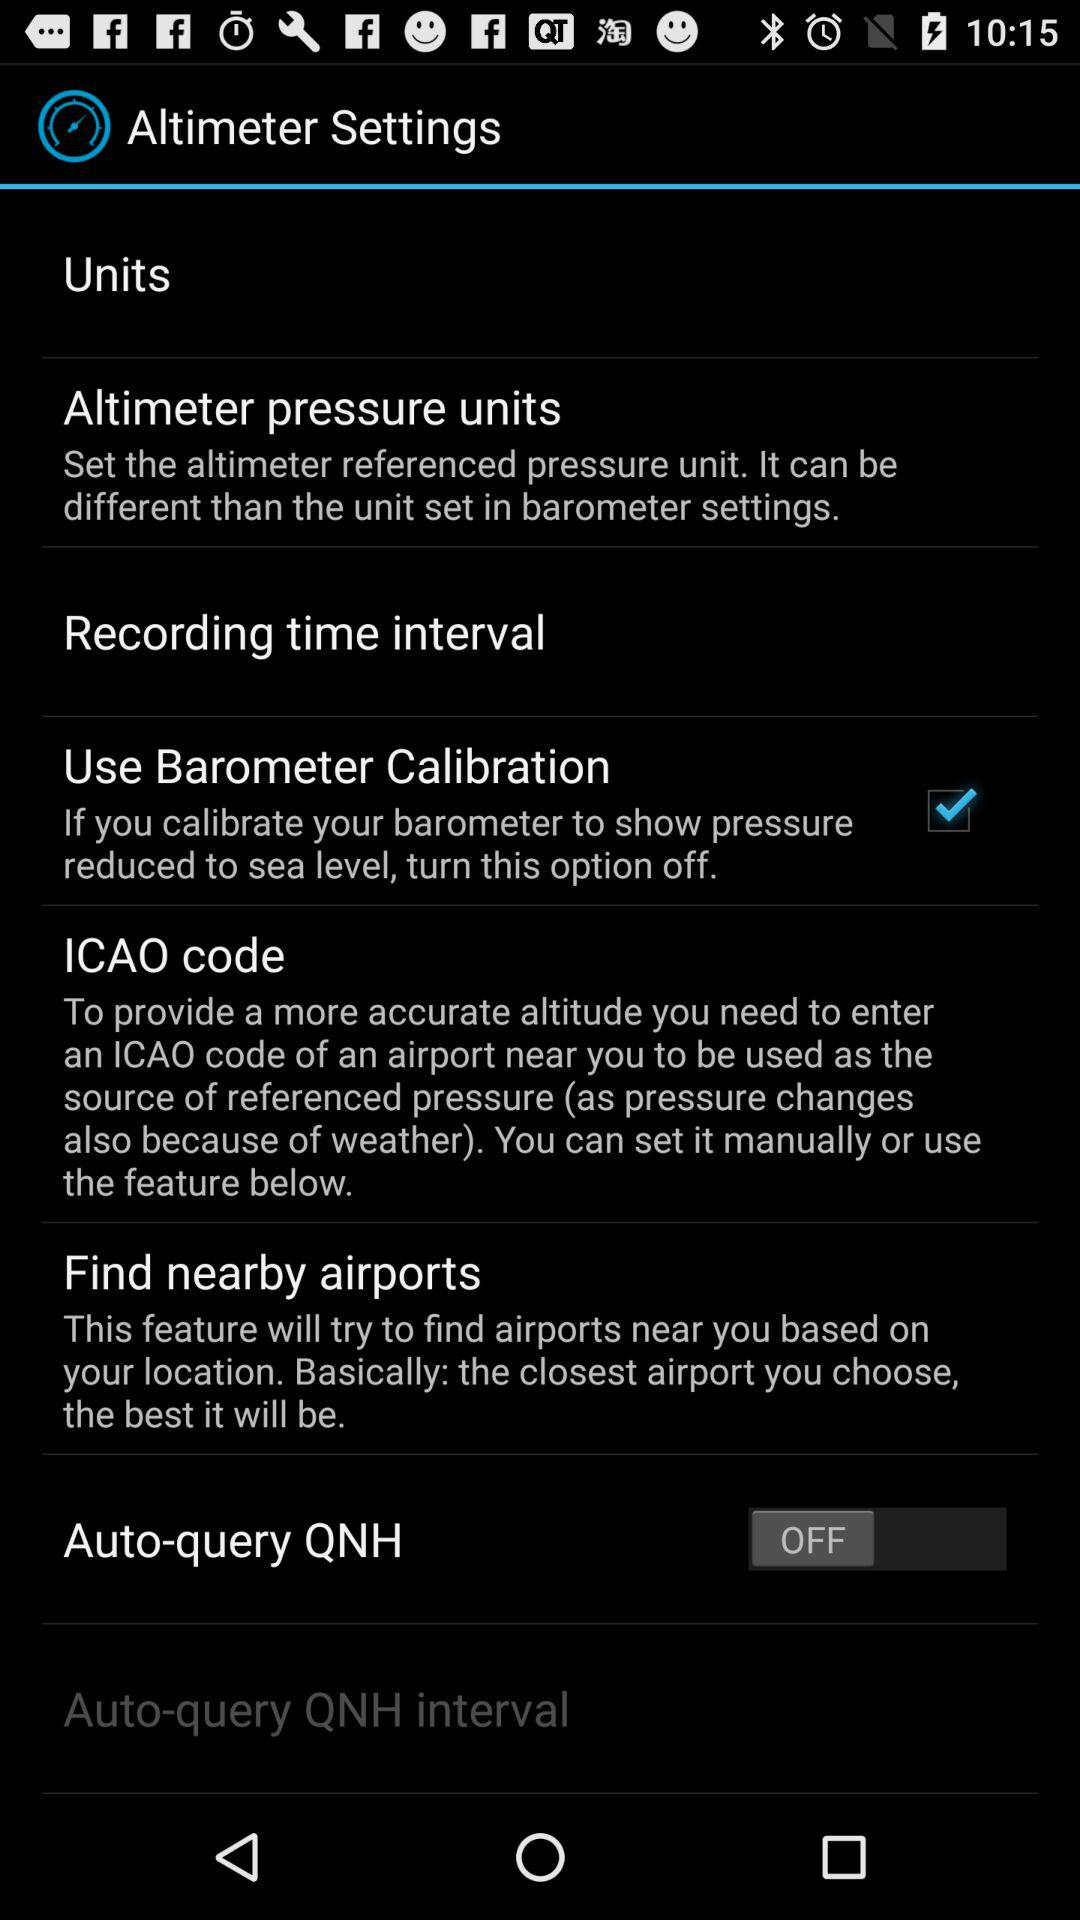What is the status of "Auto-query QNH"? The status is "OFF". 